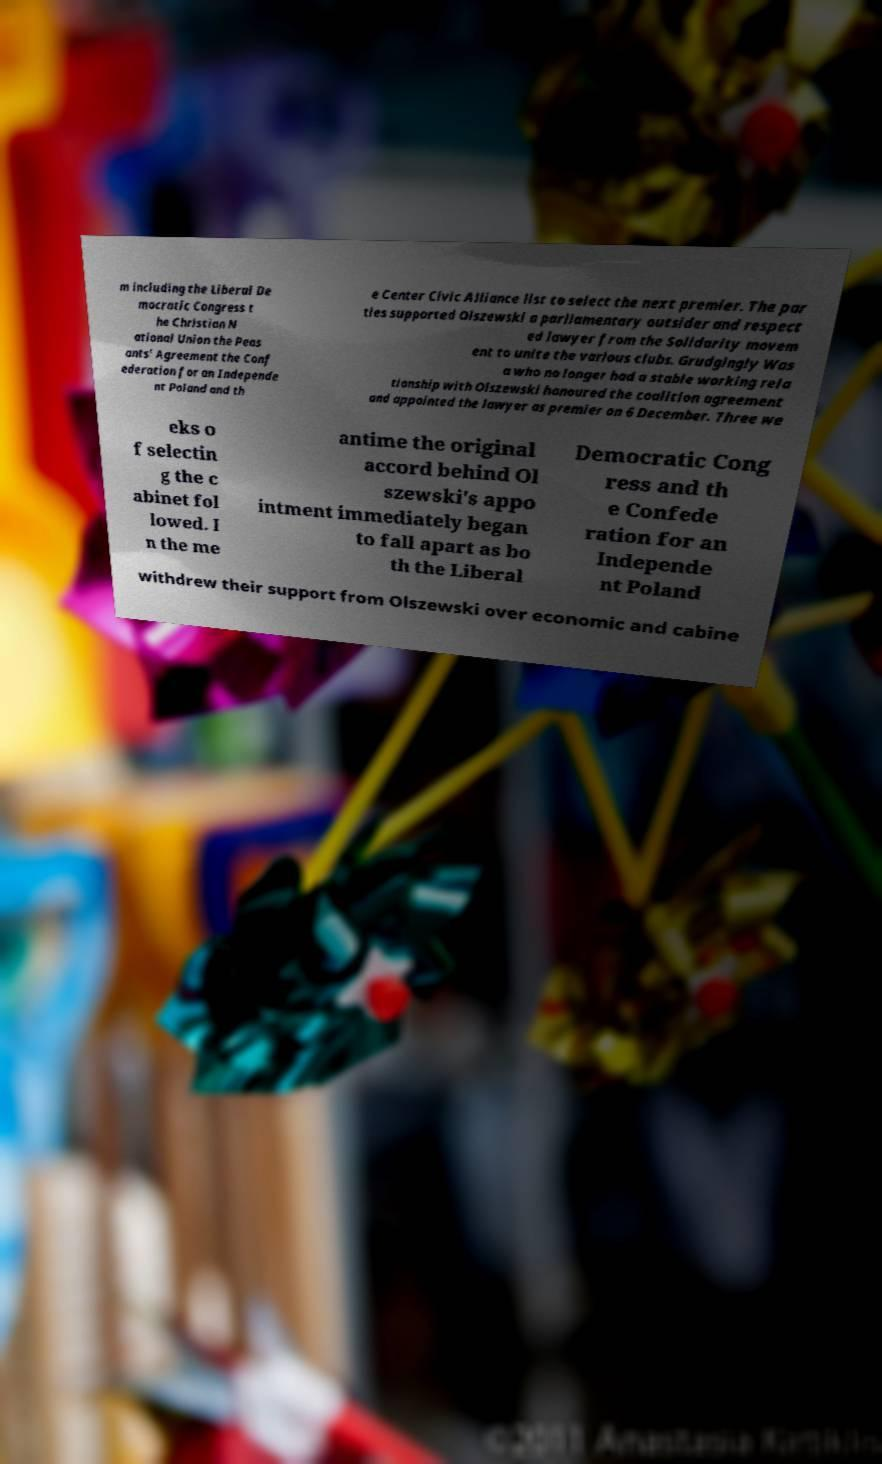Please identify and transcribe the text found in this image. m including the Liberal De mocratic Congress t he Christian N ational Union the Peas ants' Agreement the Conf ederation for an Independe nt Poland and th e Center Civic Alliance list to select the next premier. The par ties supported Olszewski a parliamentary outsider and respect ed lawyer from the Solidarity movem ent to unite the various clubs. Grudgingly Was a who no longer had a stable working rela tionship with Olszewski honoured the coalition agreement and appointed the lawyer as premier on 6 December. Three we eks o f selectin g the c abinet fol lowed. I n the me antime the original accord behind Ol szewski's appo intment immediately began to fall apart as bo th the Liberal Democratic Cong ress and th e Confede ration for an Independe nt Poland withdrew their support from Olszewski over economic and cabine 